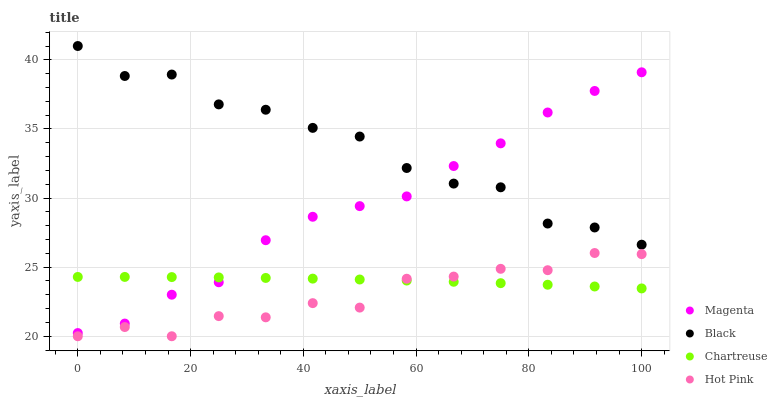Does Hot Pink have the minimum area under the curve?
Answer yes or no. Yes. Does Black have the maximum area under the curve?
Answer yes or no. Yes. Does Black have the minimum area under the curve?
Answer yes or no. No. Does Hot Pink have the maximum area under the curve?
Answer yes or no. No. Is Chartreuse the smoothest?
Answer yes or no. Yes. Is Black the roughest?
Answer yes or no. Yes. Is Hot Pink the smoothest?
Answer yes or no. No. Is Hot Pink the roughest?
Answer yes or no. No. Does Hot Pink have the lowest value?
Answer yes or no. Yes. Does Black have the lowest value?
Answer yes or no. No. Does Black have the highest value?
Answer yes or no. Yes. Does Hot Pink have the highest value?
Answer yes or no. No. Is Hot Pink less than Black?
Answer yes or no. Yes. Is Black greater than Hot Pink?
Answer yes or no. Yes. Does Chartreuse intersect Magenta?
Answer yes or no. Yes. Is Chartreuse less than Magenta?
Answer yes or no. No. Is Chartreuse greater than Magenta?
Answer yes or no. No. Does Hot Pink intersect Black?
Answer yes or no. No. 